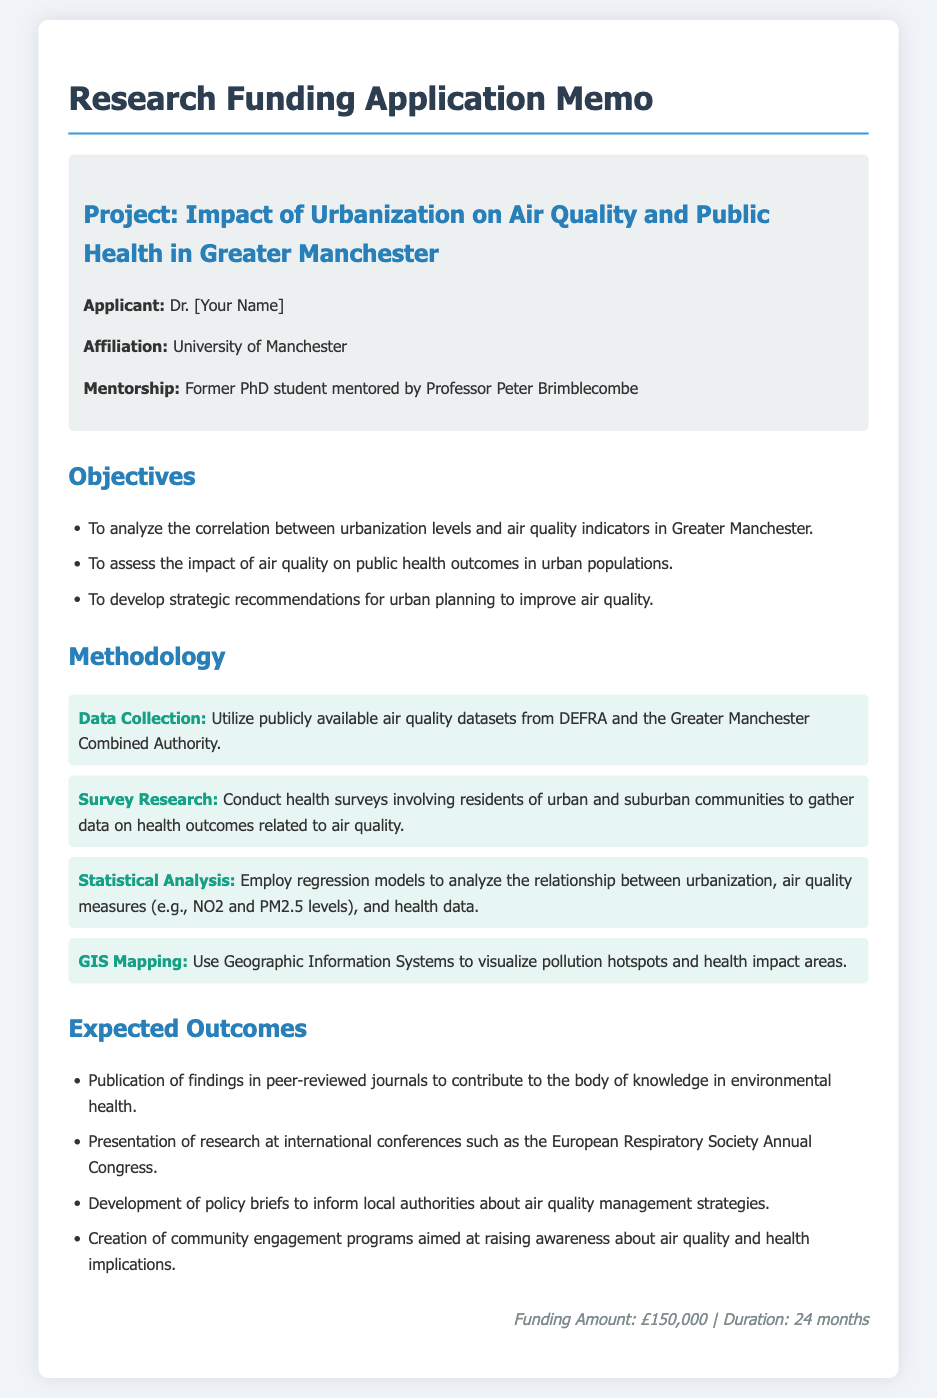What is the project title? The project title is explicitly stated in the memo under the project heading.
Answer: Impact of Urbanization on Air Quality and Public Health in Greater Manchester Who is the applicant? The applicant's name is provided in the applicant info section of the memo.
Answer: Dr. [Your Name] What is the funding amount requested? The funding amount is detailed in the footer of the memo.
Answer: £150,000 What is one of the objectives of the project? One objective is listed in the objectives section of the memo, which contains multiple points.
Answer: To analyze the correlation between urbanization levels and air quality indicators in Greater Manchester What methodology will be used for data collection? The methodology for data collection is specified in the methodology section of the memo.
Answer: Utilize publicly available air quality datasets from DEFRA and the Greater Manchester Combined Authority What is one expected outcome of the research? One expected outcome is outlined in the expected outcomes section of the memo.
Answer: Publication of findings in peer-reviewed journals to contribute to the body of knowledge in environmental health How long will the research project last? The duration of the project is mentioned in the footer of the memo.
Answer: 24 months What type of analysis will be employed in the methodology? The type of analysis is indicated in the methodology section outlining the statistical techniques to be used.
Answer: Regression models What will GIS be used for in the project? The purpose of GIS is clarified in the methodology section of the memo.
Answer: To visualize pollution hotspots and health impact areas 